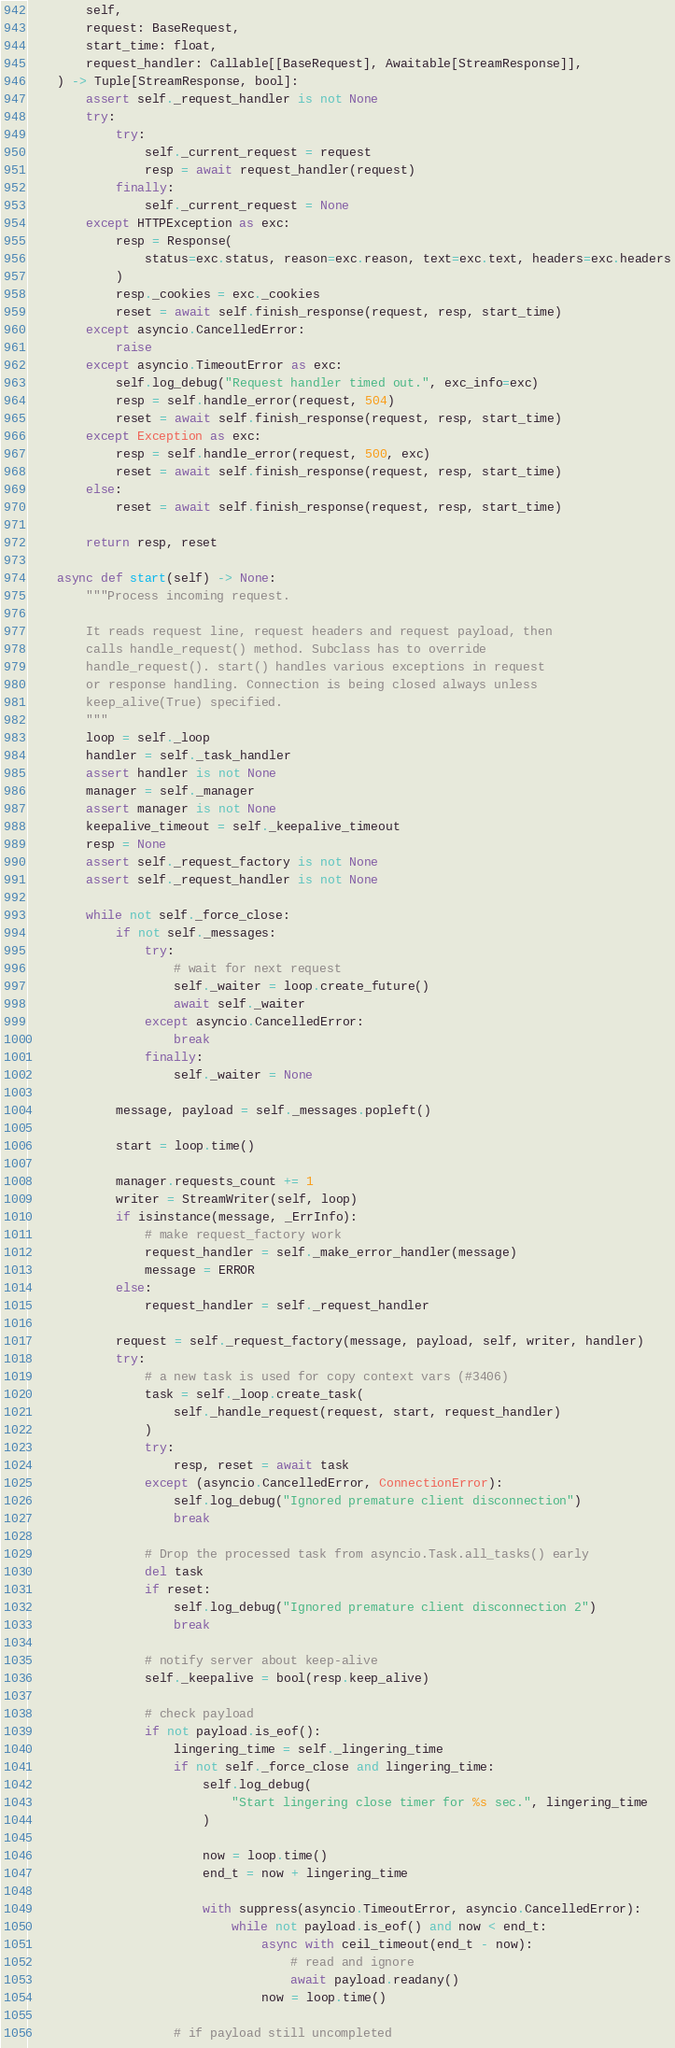<code> <loc_0><loc_0><loc_500><loc_500><_Python_>        self,
        request: BaseRequest,
        start_time: float,
        request_handler: Callable[[BaseRequest], Awaitable[StreamResponse]],
    ) -> Tuple[StreamResponse, bool]:
        assert self._request_handler is not None
        try:
            try:
                self._current_request = request
                resp = await request_handler(request)
            finally:
                self._current_request = None
        except HTTPException as exc:
            resp = Response(
                status=exc.status, reason=exc.reason, text=exc.text, headers=exc.headers
            )
            resp._cookies = exc._cookies
            reset = await self.finish_response(request, resp, start_time)
        except asyncio.CancelledError:
            raise
        except asyncio.TimeoutError as exc:
            self.log_debug("Request handler timed out.", exc_info=exc)
            resp = self.handle_error(request, 504)
            reset = await self.finish_response(request, resp, start_time)
        except Exception as exc:
            resp = self.handle_error(request, 500, exc)
            reset = await self.finish_response(request, resp, start_time)
        else:
            reset = await self.finish_response(request, resp, start_time)

        return resp, reset

    async def start(self) -> None:
        """Process incoming request.

        It reads request line, request headers and request payload, then
        calls handle_request() method. Subclass has to override
        handle_request(). start() handles various exceptions in request
        or response handling. Connection is being closed always unless
        keep_alive(True) specified.
        """
        loop = self._loop
        handler = self._task_handler
        assert handler is not None
        manager = self._manager
        assert manager is not None
        keepalive_timeout = self._keepalive_timeout
        resp = None
        assert self._request_factory is not None
        assert self._request_handler is not None

        while not self._force_close:
            if not self._messages:
                try:
                    # wait for next request
                    self._waiter = loop.create_future()
                    await self._waiter
                except asyncio.CancelledError:
                    break
                finally:
                    self._waiter = None

            message, payload = self._messages.popleft()

            start = loop.time()

            manager.requests_count += 1
            writer = StreamWriter(self, loop)
            if isinstance(message, _ErrInfo):
                # make request_factory work
                request_handler = self._make_error_handler(message)
                message = ERROR
            else:
                request_handler = self._request_handler

            request = self._request_factory(message, payload, self, writer, handler)
            try:
                # a new task is used for copy context vars (#3406)
                task = self._loop.create_task(
                    self._handle_request(request, start, request_handler)
                )
                try:
                    resp, reset = await task
                except (asyncio.CancelledError, ConnectionError):
                    self.log_debug("Ignored premature client disconnection")
                    break

                # Drop the processed task from asyncio.Task.all_tasks() early
                del task
                if reset:
                    self.log_debug("Ignored premature client disconnection 2")
                    break

                # notify server about keep-alive
                self._keepalive = bool(resp.keep_alive)

                # check payload
                if not payload.is_eof():
                    lingering_time = self._lingering_time
                    if not self._force_close and lingering_time:
                        self.log_debug(
                            "Start lingering close timer for %s sec.", lingering_time
                        )

                        now = loop.time()
                        end_t = now + lingering_time

                        with suppress(asyncio.TimeoutError, asyncio.CancelledError):
                            while not payload.is_eof() and now < end_t:
                                async with ceil_timeout(end_t - now):
                                    # read and ignore
                                    await payload.readany()
                                now = loop.time()

                    # if payload still uncompleted</code> 